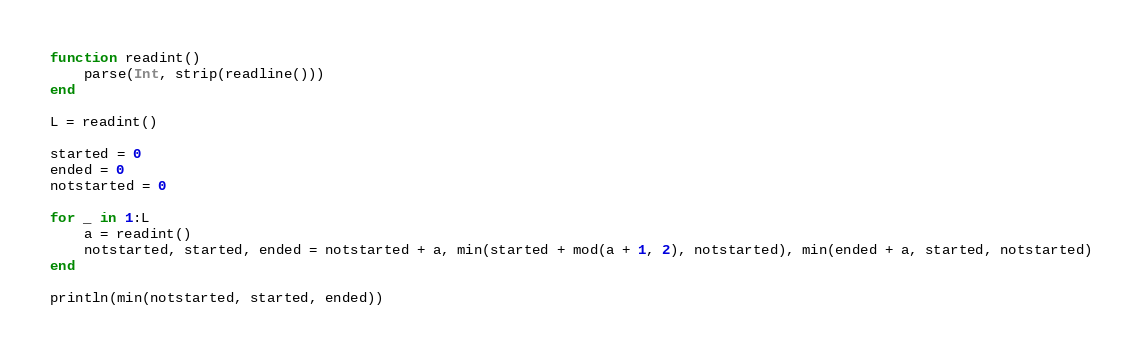<code> <loc_0><loc_0><loc_500><loc_500><_Julia_>function readint()
    parse(Int, strip(readline()))
end

L = readint()

started = 0
ended = 0
notstarted = 0

for _ in 1:L
    a = readint()
    notstarted, started, ended = notstarted + a, min(started + mod(a + 1, 2), notstarted), min(ended + a, started, notstarted)
end

println(min(notstarted, started, ended))</code> 